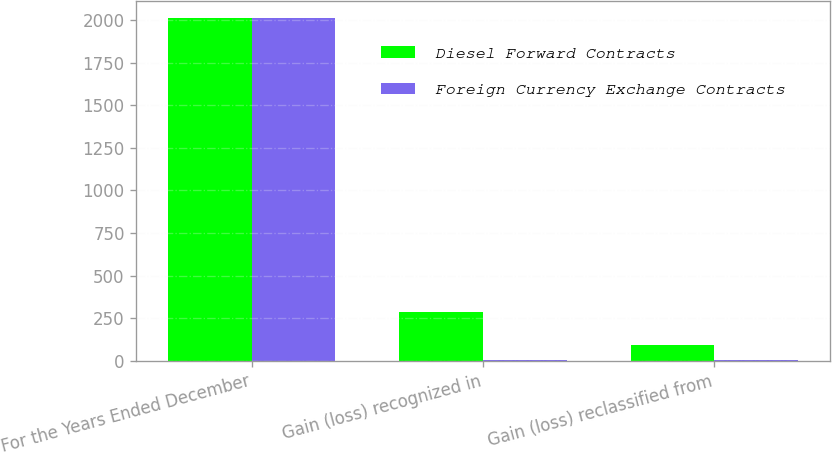Convert chart to OTSL. <chart><loc_0><loc_0><loc_500><loc_500><stacked_bar_chart><ecel><fcel>For the Years Ended December<fcel>Gain (loss) recognized in<fcel>Gain (loss) reclassified from<nl><fcel>Diesel Forward Contracts<fcel>2010<fcel>287<fcel>92<nl><fcel>Foreign Currency Exchange Contracts<fcel>2010<fcel>6<fcel>4<nl></chart> 